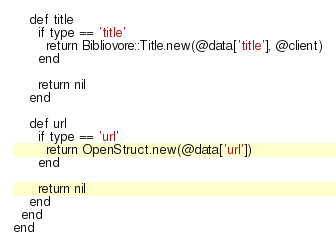Convert code to text. <code><loc_0><loc_0><loc_500><loc_500><_Ruby_>
    def title
      if type == 'title'
        return Bibliovore::Title.new(@data['title'], @client)
      end

      return nil
    end

    def url
      if type == 'url'
        return OpenStruct.new(@data['url'])
      end

      return nil
    end
  end
end

</code> 